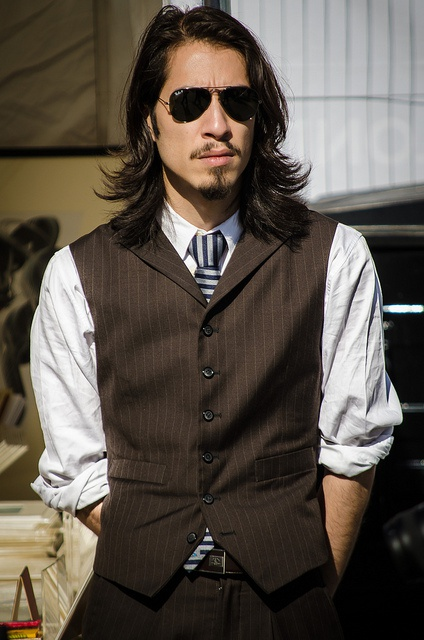Describe the objects in this image and their specific colors. I can see people in black, lightgray, and maroon tones and tie in black, gray, and darkgray tones in this image. 